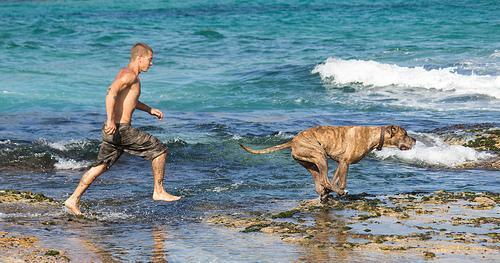How many dogs are there?
Give a very brief answer. 1. 